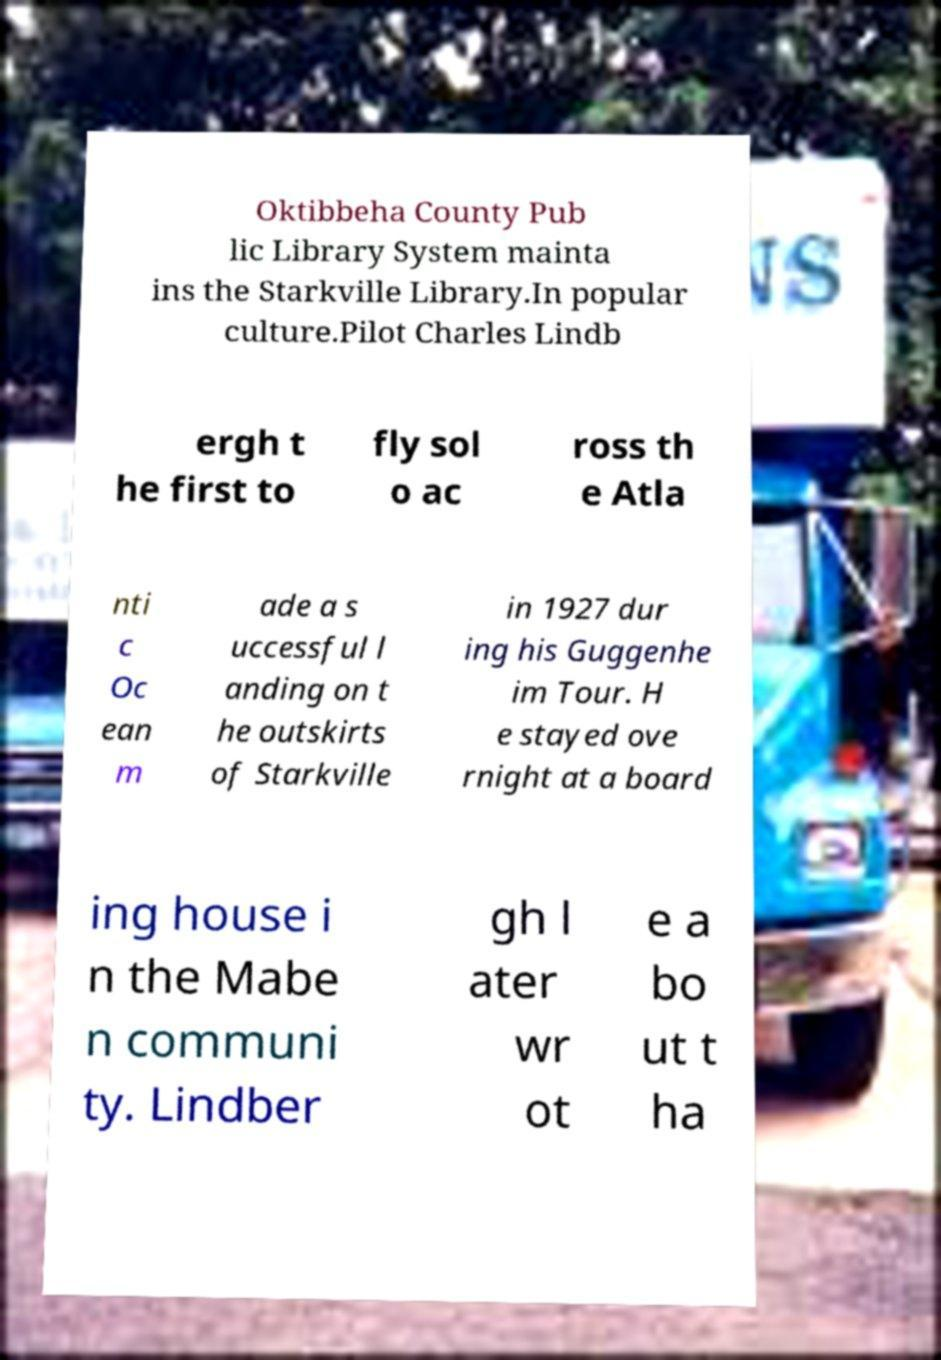Could you extract and type out the text from this image? Oktibbeha County Pub lic Library System mainta ins the Starkville Library.In popular culture.Pilot Charles Lindb ergh t he first to fly sol o ac ross th e Atla nti c Oc ean m ade a s uccessful l anding on t he outskirts of Starkville in 1927 dur ing his Guggenhe im Tour. H e stayed ove rnight at a board ing house i n the Mabe n communi ty. Lindber gh l ater wr ot e a bo ut t ha 